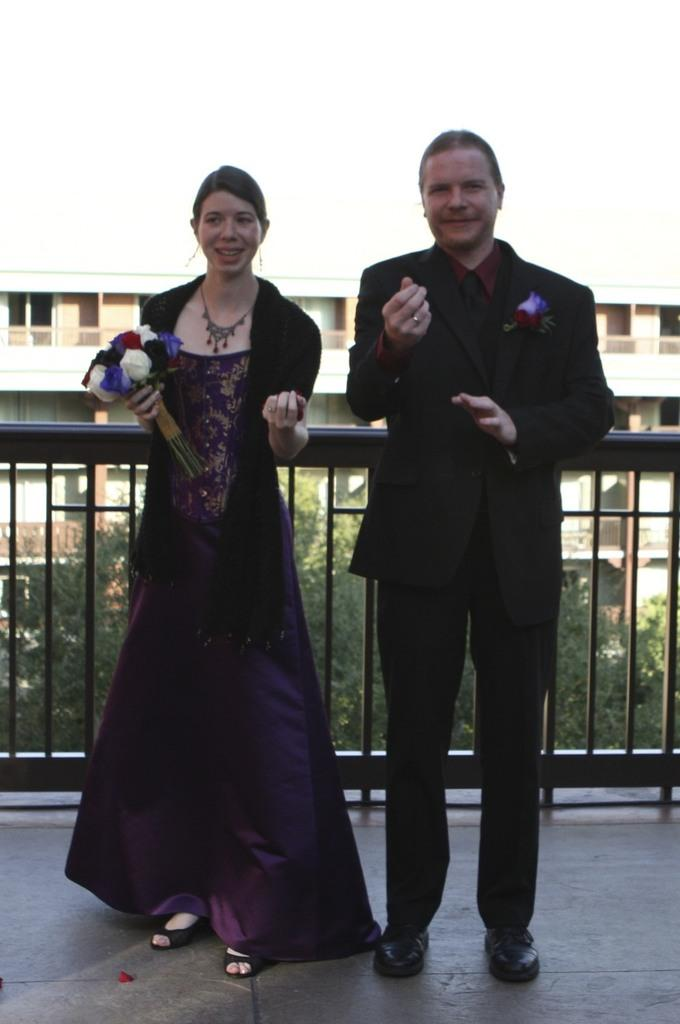How many people are present in the image? There are two people, a man and a woman, present in the image. What is the woman holding in the image? The woman is holding flowers. What can be seen in the background of the image? There is a building and trees visible in the image. What type of yak can be seen in the image? There is no yak present in the image. What shape is the building in the image? The provided facts do not mention the shape of the building in the image. 